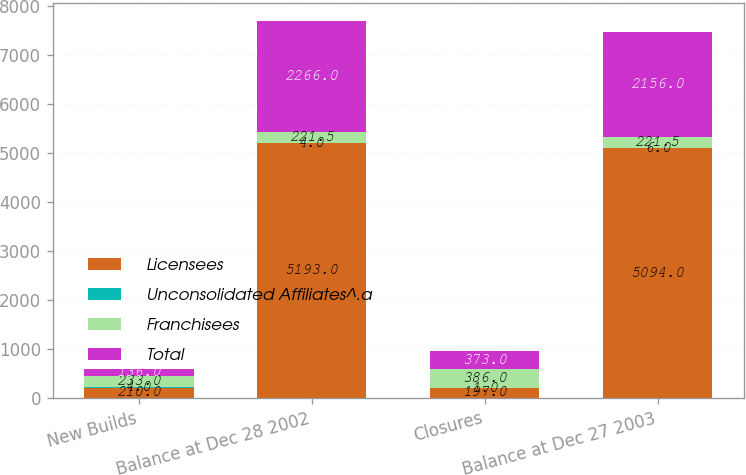<chart> <loc_0><loc_0><loc_500><loc_500><stacked_bar_chart><ecel><fcel>New Builds<fcel>Balance at Dec 28 2002<fcel>Closures<fcel>Balance at Dec 27 2003<nl><fcel>Licensees<fcel>210<fcel>5193<fcel>197<fcel>5094<nl><fcel>Unconsolidated Affiliates^.a<fcel>4<fcel>4<fcel>1<fcel>6<nl><fcel>Franchisees<fcel>233<fcel>221.5<fcel>386<fcel>221.5<nl><fcel>Total<fcel>136<fcel>2266<fcel>373<fcel>2156<nl></chart> 